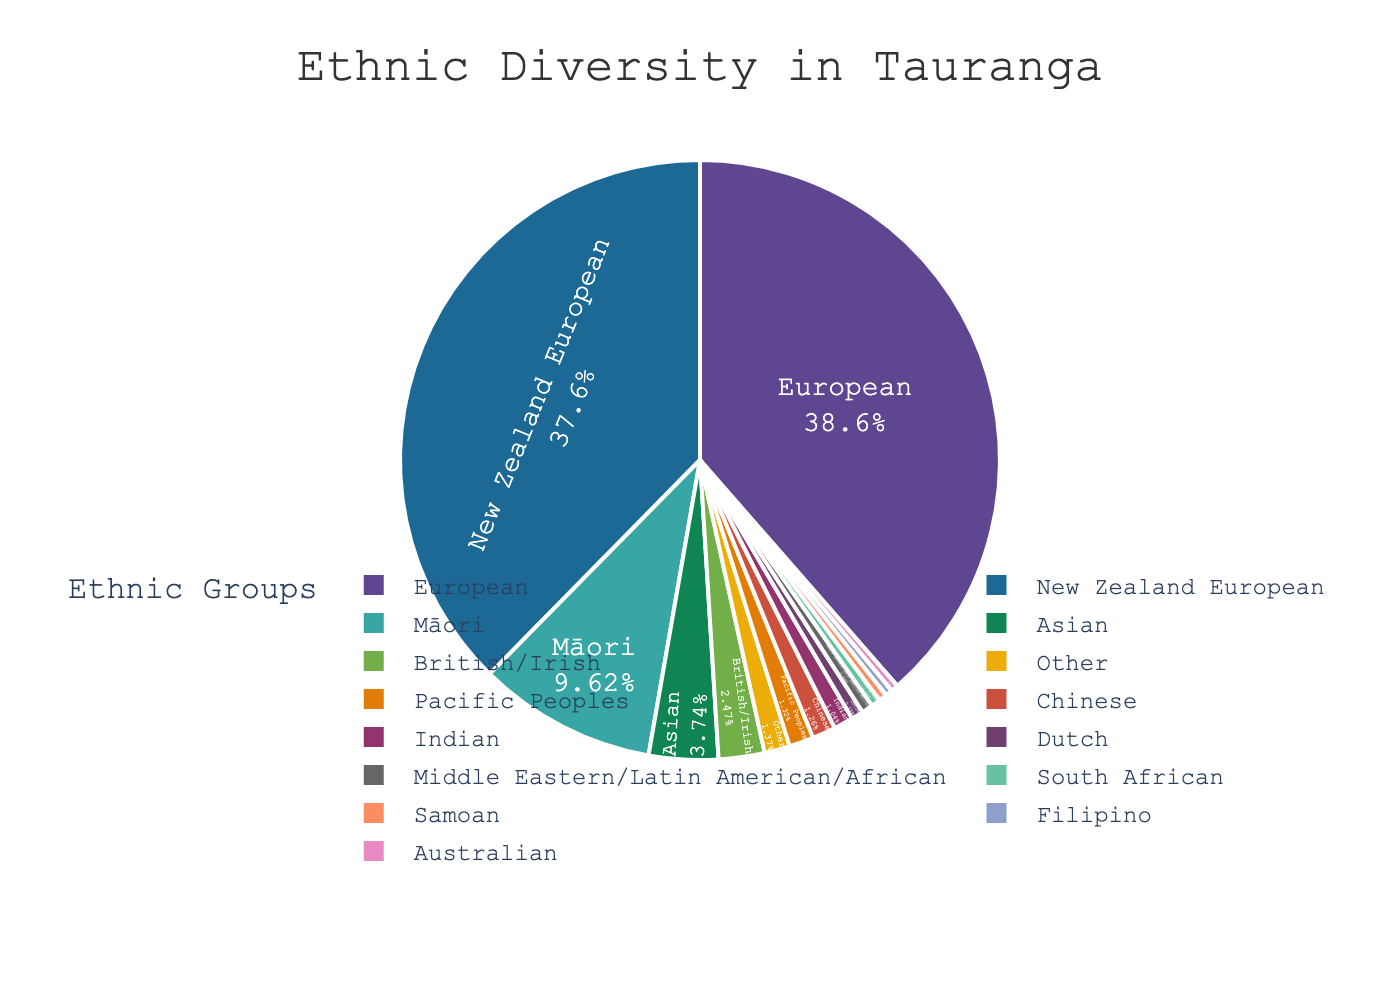Which ethnic group has the largest percentage? The pie chart shows the distribution of ethnic groups by percentage. The largest segment is labeled "European" with 70.2%.
Answer: European What is the combined percentage of Māori and Pacific Peoples? The percentages for Māori and Pacific Peoples are 17.5% and 2.4% respectively. Adding these together gives 17.5 + 2.4 = 19.9%.
Answer: 19.9% Which ethnic group is represented with a blue color in the pie chart? Observing the colored segments and their corresponding labels, European is depicted in blue.
Answer: European How much larger is the percentage of Asians than Pacific Peoples? The percentage for Asians is 6.8% and for Pacific Peoples is 2.4%. The difference is 6.8 - 2.4 = 4.4%.
Answer: 4.4% What's the combined percentage for European and New Zealand European groups? The percentage for European is 70.2% and for New Zealand European is 68.5%. Adding these together gives 70.2 + 68.5 = 138.7%.
Answer: 138.7% Which has a higher percentage: Chinese or Indian? The chart shows Chinese as 2.3% and Indian as 1.9%. Therefore, Chinese has a higher percentage than Indian.
Answer: Chinese Is the percentage of British/Irish higher than Dutch? The chart shows British/Irish at 4.5% and Dutch at 1.2%. British/Irish is higher.
Answer: Yes What is the smallest ethnic group represented on the chart? The chart indicates the smallest ethnic group is Middle Eastern/Latin American/African at 1.1%.
Answer: Middle Eastern/Latin American/African What is the total percentage of all Pacific groups (Pacific Peoples and Samoan)? The percentages for Pacific Peoples and Samoan are 2.4% and 0.8% respectively. Adding these together gives 2.4 + 0.8 = 3.2%.
Answer: 3.2% How much larger is the percentage of Europeans compared to the combined percentage of South African and Australian? The percentage of Europeans is 70.2%. The combined percentage of South African (0.9%) and Australian (0.7%) is 0.9 + 0.7 = 1.6%. The difference is 70.2 - 1.6 = 68.6%.
Answer: 68.6% 